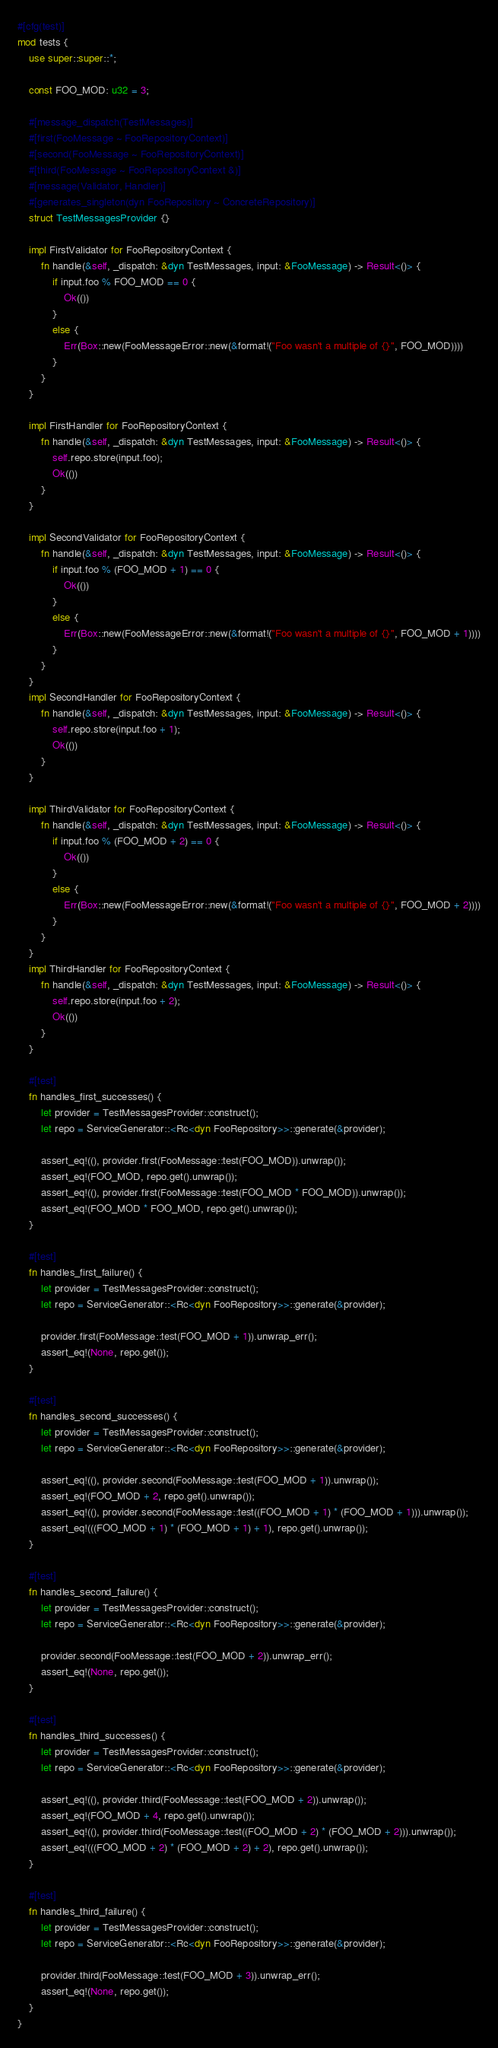Convert code to text. <code><loc_0><loc_0><loc_500><loc_500><_Rust_>#[cfg(test)]
mod tests {
    use super::super::*;

    const FOO_MOD: u32 = 3;

    #[message_dispatch(TestMessages)]
    #[first(FooMessage ~ FooRepositoryContext)]
    #[second(FooMessage ~ FooRepositoryContext)]
    #[third(FooMessage ~ FooRepositoryContext &)]
    #[message(Validator, Handler)]
    #[generates_singleton(dyn FooRepository ~ ConcreteRepository)]
    struct TestMessagesProvider {}

    impl FirstValidator for FooRepositoryContext {
        fn handle(&self, _dispatch: &dyn TestMessages, input: &FooMessage) -> Result<()> {
            if input.foo % FOO_MOD == 0 {
                Ok(())
            }
            else {
                Err(Box::new(FooMessageError::new(&format!("Foo wasn't a multiple of {}", FOO_MOD))))
            }
        }
    }

    impl FirstHandler for FooRepositoryContext {
        fn handle(&self, _dispatch: &dyn TestMessages, input: &FooMessage) -> Result<()> {
            self.repo.store(input.foo);
            Ok(())
        }
    }

    impl SecondValidator for FooRepositoryContext {
        fn handle(&self, _dispatch: &dyn TestMessages, input: &FooMessage) -> Result<()> {
            if input.foo % (FOO_MOD + 1) == 0 {
                Ok(())
            }
            else {
                Err(Box::new(FooMessageError::new(&format!("Foo wasn't a multiple of {}", FOO_MOD + 1))))
            }
        }
    }
    impl SecondHandler for FooRepositoryContext {
        fn handle(&self, _dispatch: &dyn TestMessages, input: &FooMessage) -> Result<()> {
            self.repo.store(input.foo + 1);
            Ok(())
        }
    }

    impl ThirdValidator for FooRepositoryContext {
        fn handle(&self, _dispatch: &dyn TestMessages, input: &FooMessage) -> Result<()> {
            if input.foo % (FOO_MOD + 2) == 0 {
                Ok(())
            }
            else {
                Err(Box::new(FooMessageError::new(&format!("Foo wasn't a multiple of {}", FOO_MOD + 2))))
            }
        }
    }
    impl ThirdHandler for FooRepositoryContext {
        fn handle(&self, _dispatch: &dyn TestMessages, input: &FooMessage) -> Result<()> {
            self.repo.store(input.foo + 2);
            Ok(())
        }
    }

    #[test]
    fn handles_first_successes() {
        let provider = TestMessagesProvider::construct();
        let repo = ServiceGenerator::<Rc<dyn FooRepository>>::generate(&provider);

        assert_eq!((), provider.first(FooMessage::test(FOO_MOD)).unwrap());
        assert_eq!(FOO_MOD, repo.get().unwrap());
        assert_eq!((), provider.first(FooMessage::test(FOO_MOD * FOO_MOD)).unwrap());
        assert_eq!(FOO_MOD * FOO_MOD, repo.get().unwrap());
    }

    #[test]
    fn handles_first_failure() {
        let provider = TestMessagesProvider::construct();
        let repo = ServiceGenerator::<Rc<dyn FooRepository>>::generate(&provider);

        provider.first(FooMessage::test(FOO_MOD + 1)).unwrap_err();
        assert_eq!(None, repo.get());
    }

    #[test]
    fn handles_second_successes() {
        let provider = TestMessagesProvider::construct();
        let repo = ServiceGenerator::<Rc<dyn FooRepository>>::generate(&provider);

        assert_eq!((), provider.second(FooMessage::test(FOO_MOD + 1)).unwrap());
        assert_eq!(FOO_MOD + 2, repo.get().unwrap());
        assert_eq!((), provider.second(FooMessage::test((FOO_MOD + 1) * (FOO_MOD + 1))).unwrap());
        assert_eq!(((FOO_MOD + 1) * (FOO_MOD + 1) + 1), repo.get().unwrap());
    }

    #[test]
    fn handles_second_failure() {
        let provider = TestMessagesProvider::construct();
        let repo = ServiceGenerator::<Rc<dyn FooRepository>>::generate(&provider);

        provider.second(FooMessage::test(FOO_MOD + 2)).unwrap_err();
        assert_eq!(None, repo.get());
    }

    #[test]
    fn handles_third_successes() {
        let provider = TestMessagesProvider::construct();
        let repo = ServiceGenerator::<Rc<dyn FooRepository>>::generate(&provider);

        assert_eq!((), provider.third(FooMessage::test(FOO_MOD + 2)).unwrap());
        assert_eq!(FOO_MOD + 4, repo.get().unwrap());
        assert_eq!((), provider.third(FooMessage::test((FOO_MOD + 2) * (FOO_MOD + 2))).unwrap());
        assert_eq!(((FOO_MOD + 2) * (FOO_MOD + 2) + 2), repo.get().unwrap());
    }

    #[test]
    fn handles_third_failure() {
        let provider = TestMessagesProvider::construct();
        let repo = ServiceGenerator::<Rc<dyn FooRepository>>::generate(&provider);

        provider.third(FooMessage::test(FOO_MOD + 3)).unwrap_err();
        assert_eq!(None, repo.get());
    }
}</code> 